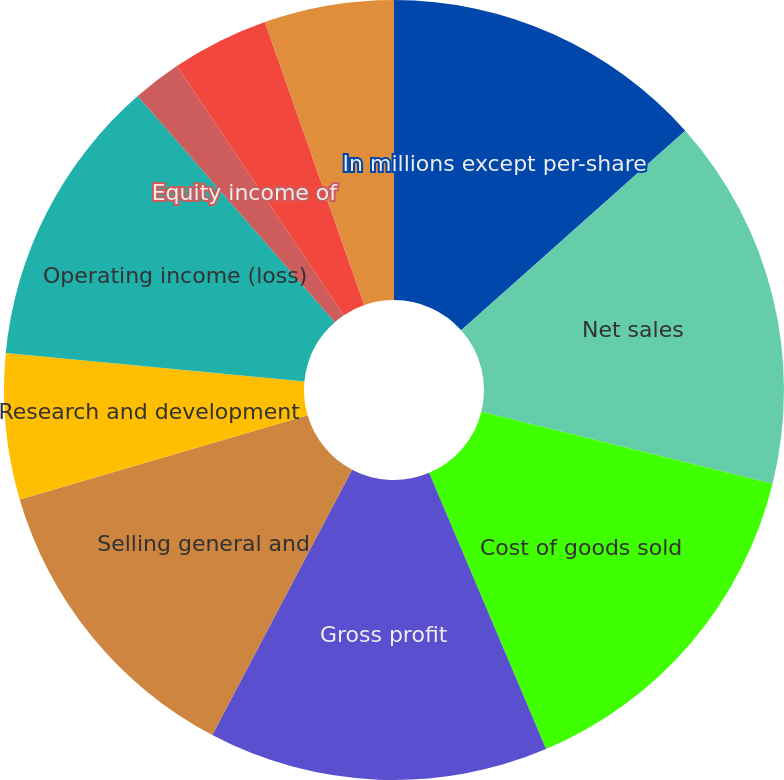Convert chart to OTSL. <chart><loc_0><loc_0><loc_500><loc_500><pie_chart><fcel>In millions except per-share<fcel>Net sales<fcel>Cost of goods sold<fcel>Gross profit<fcel>Selling general and<fcel>Research and development<fcel>Operating income (loss)<fcel>Equity income of<fcel>Interest income<fcel>Interest expense<nl><fcel>13.42%<fcel>15.44%<fcel>14.76%<fcel>14.09%<fcel>12.75%<fcel>6.04%<fcel>12.08%<fcel>2.01%<fcel>4.03%<fcel>5.37%<nl></chart> 